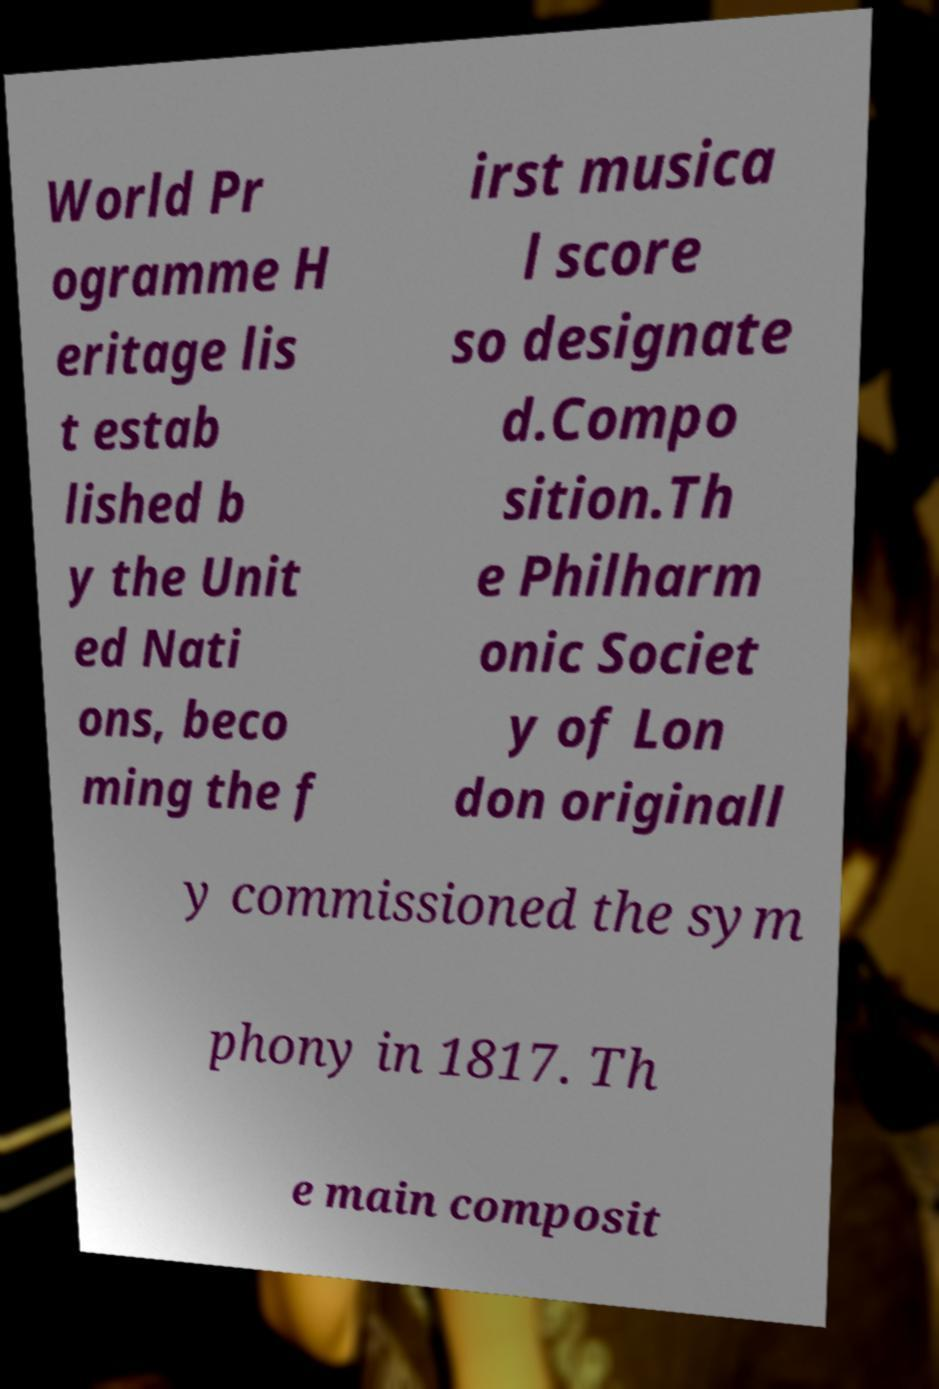Could you assist in decoding the text presented in this image and type it out clearly? World Pr ogramme H eritage lis t estab lished b y the Unit ed Nati ons, beco ming the f irst musica l score so designate d.Compo sition.Th e Philharm onic Societ y of Lon don originall y commissioned the sym phony in 1817. Th e main composit 